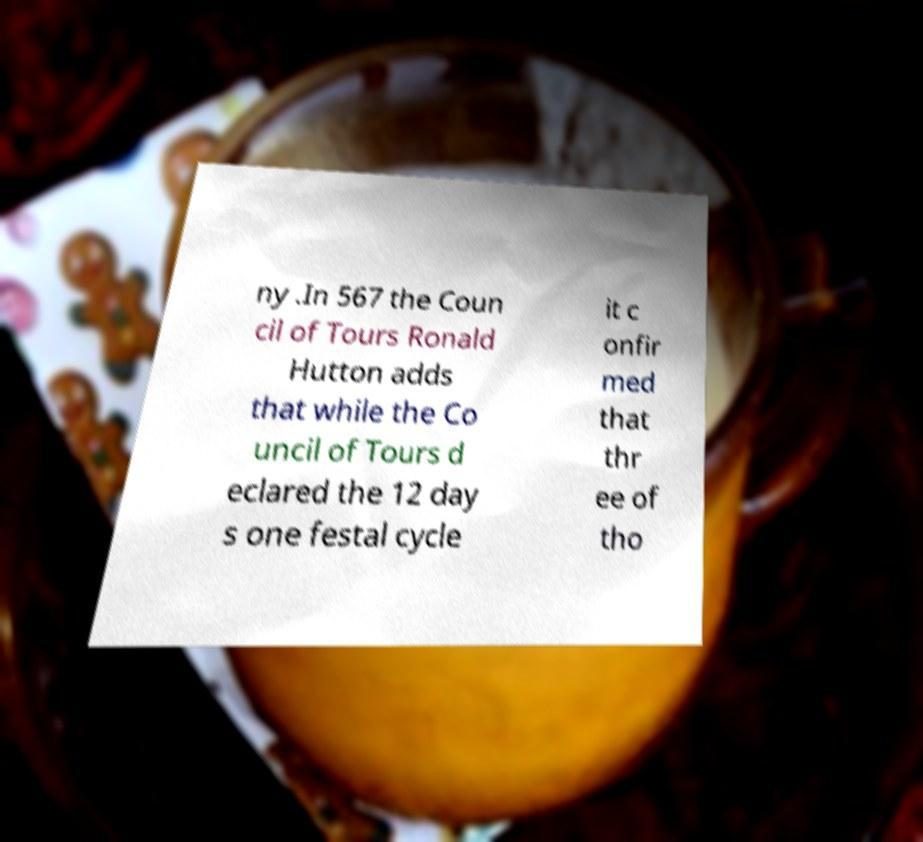Could you assist in decoding the text presented in this image and type it out clearly? ny .In 567 the Coun cil of Tours Ronald Hutton adds that while the Co uncil of Tours d eclared the 12 day s one festal cycle it c onfir med that thr ee of tho 